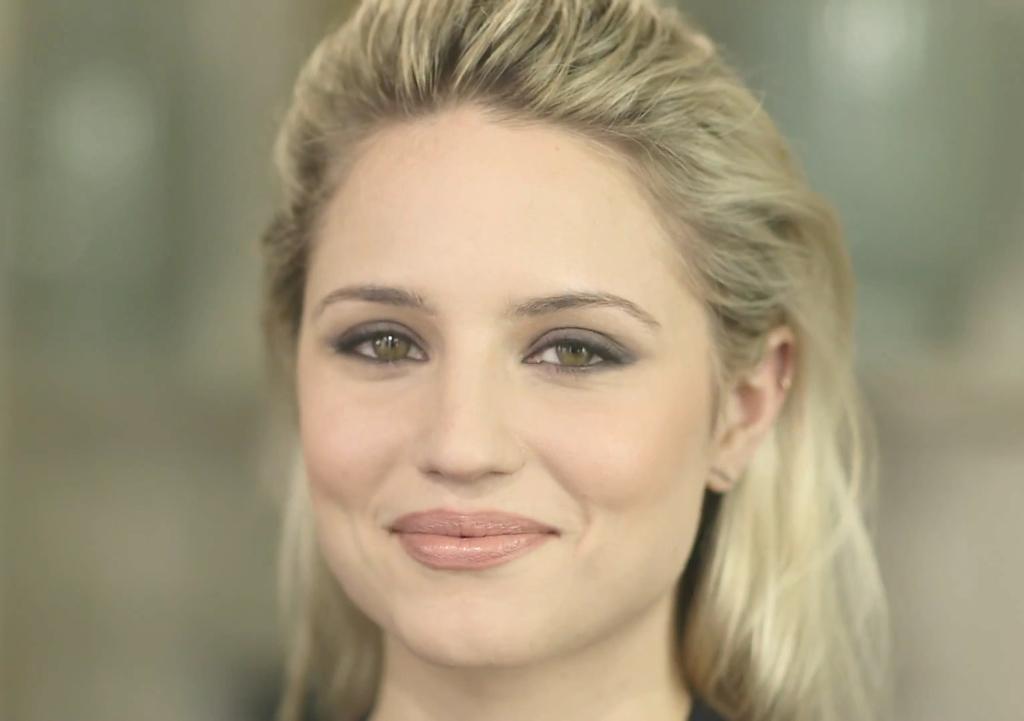Could you give a brief overview of what you see in this image? There is a woman smiling. In the background it is blur. 